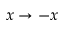Convert formula to latex. <formula><loc_0><loc_0><loc_500><loc_500>x \to - x</formula> 